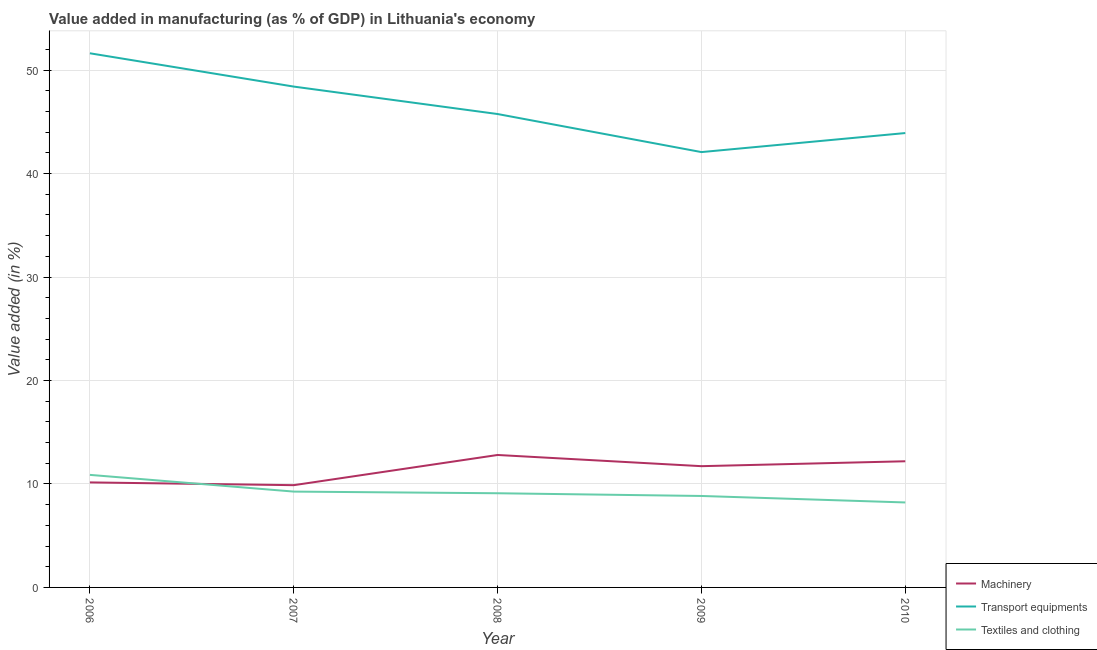How many different coloured lines are there?
Provide a succinct answer. 3. Is the number of lines equal to the number of legend labels?
Provide a succinct answer. Yes. What is the value added in manufacturing textile and clothing in 2009?
Make the answer very short. 8.84. Across all years, what is the maximum value added in manufacturing textile and clothing?
Offer a terse response. 10.88. Across all years, what is the minimum value added in manufacturing transport equipments?
Your response must be concise. 42.08. What is the total value added in manufacturing machinery in the graph?
Keep it short and to the point. 56.75. What is the difference between the value added in manufacturing transport equipments in 2009 and that in 2010?
Offer a very short reply. -1.84. What is the difference between the value added in manufacturing machinery in 2008 and the value added in manufacturing textile and clothing in 2007?
Make the answer very short. 3.54. What is the average value added in manufacturing transport equipments per year?
Provide a succinct answer. 46.36. In the year 2009, what is the difference between the value added in manufacturing textile and clothing and value added in manufacturing machinery?
Your answer should be compact. -2.88. What is the ratio of the value added in manufacturing machinery in 2008 to that in 2010?
Make the answer very short. 1.05. Is the difference between the value added in manufacturing transport equipments in 2007 and 2008 greater than the difference between the value added in manufacturing textile and clothing in 2007 and 2008?
Your response must be concise. Yes. What is the difference between the highest and the second highest value added in manufacturing textile and clothing?
Your answer should be very brief. 1.62. What is the difference between the highest and the lowest value added in manufacturing textile and clothing?
Keep it short and to the point. 2.67. Is the sum of the value added in manufacturing textile and clothing in 2009 and 2010 greater than the maximum value added in manufacturing machinery across all years?
Your answer should be very brief. Yes. Is it the case that in every year, the sum of the value added in manufacturing machinery and value added in manufacturing transport equipments is greater than the value added in manufacturing textile and clothing?
Make the answer very short. Yes. Is the value added in manufacturing machinery strictly less than the value added in manufacturing transport equipments over the years?
Your answer should be compact. Yes. How many lines are there?
Offer a terse response. 3. Are the values on the major ticks of Y-axis written in scientific E-notation?
Your answer should be compact. No. Does the graph contain grids?
Provide a short and direct response. Yes. Where does the legend appear in the graph?
Keep it short and to the point. Bottom right. What is the title of the graph?
Make the answer very short. Value added in manufacturing (as % of GDP) in Lithuania's economy. Does "Transport equipments" appear as one of the legend labels in the graph?
Offer a terse response. Yes. What is the label or title of the Y-axis?
Give a very brief answer. Value added (in %). What is the Value added (in %) of Machinery in 2006?
Your answer should be very brief. 10.15. What is the Value added (in %) in Transport equipments in 2006?
Your response must be concise. 51.63. What is the Value added (in %) in Textiles and clothing in 2006?
Your response must be concise. 10.88. What is the Value added (in %) in Machinery in 2007?
Keep it short and to the point. 9.88. What is the Value added (in %) in Transport equipments in 2007?
Provide a succinct answer. 48.41. What is the Value added (in %) of Textiles and clothing in 2007?
Provide a short and direct response. 9.26. What is the Value added (in %) of Machinery in 2008?
Make the answer very short. 12.8. What is the Value added (in %) of Transport equipments in 2008?
Provide a succinct answer. 45.76. What is the Value added (in %) of Textiles and clothing in 2008?
Provide a succinct answer. 9.1. What is the Value added (in %) of Machinery in 2009?
Your answer should be compact. 11.72. What is the Value added (in %) of Transport equipments in 2009?
Offer a very short reply. 42.08. What is the Value added (in %) of Textiles and clothing in 2009?
Your answer should be compact. 8.84. What is the Value added (in %) of Machinery in 2010?
Give a very brief answer. 12.19. What is the Value added (in %) in Transport equipments in 2010?
Provide a succinct answer. 43.92. What is the Value added (in %) in Textiles and clothing in 2010?
Make the answer very short. 8.21. Across all years, what is the maximum Value added (in %) in Machinery?
Your answer should be compact. 12.8. Across all years, what is the maximum Value added (in %) in Transport equipments?
Offer a very short reply. 51.63. Across all years, what is the maximum Value added (in %) of Textiles and clothing?
Give a very brief answer. 10.88. Across all years, what is the minimum Value added (in %) of Machinery?
Your response must be concise. 9.88. Across all years, what is the minimum Value added (in %) of Transport equipments?
Provide a succinct answer. 42.08. Across all years, what is the minimum Value added (in %) in Textiles and clothing?
Ensure brevity in your answer.  8.21. What is the total Value added (in %) of Machinery in the graph?
Offer a very short reply. 56.75. What is the total Value added (in %) of Transport equipments in the graph?
Provide a short and direct response. 231.79. What is the total Value added (in %) of Textiles and clothing in the graph?
Keep it short and to the point. 46.3. What is the difference between the Value added (in %) of Machinery in 2006 and that in 2007?
Give a very brief answer. 0.27. What is the difference between the Value added (in %) of Transport equipments in 2006 and that in 2007?
Provide a short and direct response. 3.22. What is the difference between the Value added (in %) in Textiles and clothing in 2006 and that in 2007?
Your answer should be compact. 1.62. What is the difference between the Value added (in %) of Machinery in 2006 and that in 2008?
Provide a short and direct response. -2.65. What is the difference between the Value added (in %) in Transport equipments in 2006 and that in 2008?
Give a very brief answer. 5.87. What is the difference between the Value added (in %) in Textiles and clothing in 2006 and that in 2008?
Make the answer very short. 1.78. What is the difference between the Value added (in %) in Machinery in 2006 and that in 2009?
Provide a succinct answer. -1.57. What is the difference between the Value added (in %) in Transport equipments in 2006 and that in 2009?
Your response must be concise. 9.55. What is the difference between the Value added (in %) in Textiles and clothing in 2006 and that in 2009?
Provide a succinct answer. 2.04. What is the difference between the Value added (in %) of Machinery in 2006 and that in 2010?
Provide a short and direct response. -2.04. What is the difference between the Value added (in %) of Transport equipments in 2006 and that in 2010?
Your response must be concise. 7.71. What is the difference between the Value added (in %) in Textiles and clothing in 2006 and that in 2010?
Offer a terse response. 2.67. What is the difference between the Value added (in %) in Machinery in 2007 and that in 2008?
Make the answer very short. -2.92. What is the difference between the Value added (in %) in Transport equipments in 2007 and that in 2008?
Ensure brevity in your answer.  2.65. What is the difference between the Value added (in %) of Textiles and clothing in 2007 and that in 2008?
Make the answer very short. 0.16. What is the difference between the Value added (in %) of Machinery in 2007 and that in 2009?
Make the answer very short. -1.84. What is the difference between the Value added (in %) in Transport equipments in 2007 and that in 2009?
Make the answer very short. 6.33. What is the difference between the Value added (in %) of Textiles and clothing in 2007 and that in 2009?
Make the answer very short. 0.42. What is the difference between the Value added (in %) in Machinery in 2007 and that in 2010?
Give a very brief answer. -2.31. What is the difference between the Value added (in %) of Transport equipments in 2007 and that in 2010?
Your answer should be very brief. 4.49. What is the difference between the Value added (in %) of Textiles and clothing in 2007 and that in 2010?
Keep it short and to the point. 1.05. What is the difference between the Value added (in %) of Machinery in 2008 and that in 2009?
Your response must be concise. 1.08. What is the difference between the Value added (in %) of Transport equipments in 2008 and that in 2009?
Provide a succinct answer. 3.68. What is the difference between the Value added (in %) in Textiles and clothing in 2008 and that in 2009?
Offer a terse response. 0.26. What is the difference between the Value added (in %) of Machinery in 2008 and that in 2010?
Provide a short and direct response. 0.61. What is the difference between the Value added (in %) of Transport equipments in 2008 and that in 2010?
Ensure brevity in your answer.  1.84. What is the difference between the Value added (in %) of Textiles and clothing in 2008 and that in 2010?
Provide a succinct answer. 0.89. What is the difference between the Value added (in %) in Machinery in 2009 and that in 2010?
Offer a very short reply. -0.47. What is the difference between the Value added (in %) in Transport equipments in 2009 and that in 2010?
Your answer should be compact. -1.84. What is the difference between the Value added (in %) of Textiles and clothing in 2009 and that in 2010?
Provide a short and direct response. 0.63. What is the difference between the Value added (in %) of Machinery in 2006 and the Value added (in %) of Transport equipments in 2007?
Your answer should be compact. -38.26. What is the difference between the Value added (in %) of Machinery in 2006 and the Value added (in %) of Textiles and clothing in 2007?
Offer a very short reply. 0.89. What is the difference between the Value added (in %) of Transport equipments in 2006 and the Value added (in %) of Textiles and clothing in 2007?
Ensure brevity in your answer.  42.37. What is the difference between the Value added (in %) of Machinery in 2006 and the Value added (in %) of Transport equipments in 2008?
Your response must be concise. -35.61. What is the difference between the Value added (in %) of Machinery in 2006 and the Value added (in %) of Textiles and clothing in 2008?
Provide a short and direct response. 1.05. What is the difference between the Value added (in %) of Transport equipments in 2006 and the Value added (in %) of Textiles and clothing in 2008?
Your response must be concise. 42.53. What is the difference between the Value added (in %) in Machinery in 2006 and the Value added (in %) in Transport equipments in 2009?
Ensure brevity in your answer.  -31.93. What is the difference between the Value added (in %) of Machinery in 2006 and the Value added (in %) of Textiles and clothing in 2009?
Provide a succinct answer. 1.31. What is the difference between the Value added (in %) in Transport equipments in 2006 and the Value added (in %) in Textiles and clothing in 2009?
Keep it short and to the point. 42.79. What is the difference between the Value added (in %) of Machinery in 2006 and the Value added (in %) of Transport equipments in 2010?
Offer a very short reply. -33.77. What is the difference between the Value added (in %) in Machinery in 2006 and the Value added (in %) in Textiles and clothing in 2010?
Keep it short and to the point. 1.94. What is the difference between the Value added (in %) in Transport equipments in 2006 and the Value added (in %) in Textiles and clothing in 2010?
Ensure brevity in your answer.  43.41. What is the difference between the Value added (in %) in Machinery in 2007 and the Value added (in %) in Transport equipments in 2008?
Your response must be concise. -35.87. What is the difference between the Value added (in %) in Machinery in 2007 and the Value added (in %) in Textiles and clothing in 2008?
Ensure brevity in your answer.  0.78. What is the difference between the Value added (in %) of Transport equipments in 2007 and the Value added (in %) of Textiles and clothing in 2008?
Ensure brevity in your answer.  39.31. What is the difference between the Value added (in %) of Machinery in 2007 and the Value added (in %) of Transport equipments in 2009?
Offer a terse response. -32.2. What is the difference between the Value added (in %) of Machinery in 2007 and the Value added (in %) of Textiles and clothing in 2009?
Keep it short and to the point. 1.04. What is the difference between the Value added (in %) of Transport equipments in 2007 and the Value added (in %) of Textiles and clothing in 2009?
Provide a short and direct response. 39.57. What is the difference between the Value added (in %) of Machinery in 2007 and the Value added (in %) of Transport equipments in 2010?
Your response must be concise. -34.03. What is the difference between the Value added (in %) of Machinery in 2007 and the Value added (in %) of Textiles and clothing in 2010?
Your answer should be very brief. 1.67. What is the difference between the Value added (in %) of Transport equipments in 2007 and the Value added (in %) of Textiles and clothing in 2010?
Your answer should be compact. 40.2. What is the difference between the Value added (in %) in Machinery in 2008 and the Value added (in %) in Transport equipments in 2009?
Give a very brief answer. -29.28. What is the difference between the Value added (in %) of Machinery in 2008 and the Value added (in %) of Textiles and clothing in 2009?
Provide a short and direct response. 3.96. What is the difference between the Value added (in %) in Transport equipments in 2008 and the Value added (in %) in Textiles and clothing in 2009?
Offer a terse response. 36.92. What is the difference between the Value added (in %) of Machinery in 2008 and the Value added (in %) of Transport equipments in 2010?
Your answer should be compact. -31.12. What is the difference between the Value added (in %) in Machinery in 2008 and the Value added (in %) in Textiles and clothing in 2010?
Your response must be concise. 4.59. What is the difference between the Value added (in %) in Transport equipments in 2008 and the Value added (in %) in Textiles and clothing in 2010?
Your answer should be compact. 37.54. What is the difference between the Value added (in %) of Machinery in 2009 and the Value added (in %) of Transport equipments in 2010?
Make the answer very short. -32.2. What is the difference between the Value added (in %) of Machinery in 2009 and the Value added (in %) of Textiles and clothing in 2010?
Keep it short and to the point. 3.51. What is the difference between the Value added (in %) of Transport equipments in 2009 and the Value added (in %) of Textiles and clothing in 2010?
Make the answer very short. 33.87. What is the average Value added (in %) of Machinery per year?
Offer a very short reply. 11.35. What is the average Value added (in %) of Transport equipments per year?
Provide a short and direct response. 46.36. What is the average Value added (in %) of Textiles and clothing per year?
Your answer should be compact. 9.26. In the year 2006, what is the difference between the Value added (in %) in Machinery and Value added (in %) in Transport equipments?
Give a very brief answer. -41.48. In the year 2006, what is the difference between the Value added (in %) of Machinery and Value added (in %) of Textiles and clothing?
Ensure brevity in your answer.  -0.73. In the year 2006, what is the difference between the Value added (in %) in Transport equipments and Value added (in %) in Textiles and clothing?
Your response must be concise. 40.75. In the year 2007, what is the difference between the Value added (in %) of Machinery and Value added (in %) of Transport equipments?
Give a very brief answer. -38.53. In the year 2007, what is the difference between the Value added (in %) of Machinery and Value added (in %) of Textiles and clothing?
Keep it short and to the point. 0.62. In the year 2007, what is the difference between the Value added (in %) of Transport equipments and Value added (in %) of Textiles and clothing?
Give a very brief answer. 39.15. In the year 2008, what is the difference between the Value added (in %) in Machinery and Value added (in %) in Transport equipments?
Give a very brief answer. -32.95. In the year 2008, what is the difference between the Value added (in %) in Machinery and Value added (in %) in Textiles and clothing?
Ensure brevity in your answer.  3.7. In the year 2008, what is the difference between the Value added (in %) in Transport equipments and Value added (in %) in Textiles and clothing?
Your answer should be very brief. 36.65. In the year 2009, what is the difference between the Value added (in %) in Machinery and Value added (in %) in Transport equipments?
Offer a very short reply. -30.36. In the year 2009, what is the difference between the Value added (in %) of Machinery and Value added (in %) of Textiles and clothing?
Your answer should be compact. 2.88. In the year 2009, what is the difference between the Value added (in %) in Transport equipments and Value added (in %) in Textiles and clothing?
Your answer should be compact. 33.24. In the year 2010, what is the difference between the Value added (in %) in Machinery and Value added (in %) in Transport equipments?
Your answer should be compact. -31.72. In the year 2010, what is the difference between the Value added (in %) of Machinery and Value added (in %) of Textiles and clothing?
Give a very brief answer. 3.98. In the year 2010, what is the difference between the Value added (in %) in Transport equipments and Value added (in %) in Textiles and clothing?
Your answer should be very brief. 35.7. What is the ratio of the Value added (in %) of Machinery in 2006 to that in 2007?
Make the answer very short. 1.03. What is the ratio of the Value added (in %) of Transport equipments in 2006 to that in 2007?
Give a very brief answer. 1.07. What is the ratio of the Value added (in %) of Textiles and clothing in 2006 to that in 2007?
Give a very brief answer. 1.17. What is the ratio of the Value added (in %) of Machinery in 2006 to that in 2008?
Your answer should be very brief. 0.79. What is the ratio of the Value added (in %) of Transport equipments in 2006 to that in 2008?
Give a very brief answer. 1.13. What is the ratio of the Value added (in %) of Textiles and clothing in 2006 to that in 2008?
Make the answer very short. 1.2. What is the ratio of the Value added (in %) in Machinery in 2006 to that in 2009?
Give a very brief answer. 0.87. What is the ratio of the Value added (in %) in Transport equipments in 2006 to that in 2009?
Make the answer very short. 1.23. What is the ratio of the Value added (in %) in Textiles and clothing in 2006 to that in 2009?
Keep it short and to the point. 1.23. What is the ratio of the Value added (in %) in Machinery in 2006 to that in 2010?
Your answer should be very brief. 0.83. What is the ratio of the Value added (in %) in Transport equipments in 2006 to that in 2010?
Your response must be concise. 1.18. What is the ratio of the Value added (in %) of Textiles and clothing in 2006 to that in 2010?
Your answer should be very brief. 1.32. What is the ratio of the Value added (in %) of Machinery in 2007 to that in 2008?
Provide a short and direct response. 0.77. What is the ratio of the Value added (in %) of Transport equipments in 2007 to that in 2008?
Provide a short and direct response. 1.06. What is the ratio of the Value added (in %) in Textiles and clothing in 2007 to that in 2008?
Keep it short and to the point. 1.02. What is the ratio of the Value added (in %) in Machinery in 2007 to that in 2009?
Offer a terse response. 0.84. What is the ratio of the Value added (in %) of Transport equipments in 2007 to that in 2009?
Keep it short and to the point. 1.15. What is the ratio of the Value added (in %) in Textiles and clothing in 2007 to that in 2009?
Your answer should be compact. 1.05. What is the ratio of the Value added (in %) of Machinery in 2007 to that in 2010?
Your answer should be compact. 0.81. What is the ratio of the Value added (in %) in Transport equipments in 2007 to that in 2010?
Ensure brevity in your answer.  1.1. What is the ratio of the Value added (in %) of Textiles and clothing in 2007 to that in 2010?
Provide a succinct answer. 1.13. What is the ratio of the Value added (in %) in Machinery in 2008 to that in 2009?
Your answer should be very brief. 1.09. What is the ratio of the Value added (in %) of Transport equipments in 2008 to that in 2009?
Ensure brevity in your answer.  1.09. What is the ratio of the Value added (in %) of Textiles and clothing in 2008 to that in 2009?
Offer a very short reply. 1.03. What is the ratio of the Value added (in %) of Machinery in 2008 to that in 2010?
Give a very brief answer. 1.05. What is the ratio of the Value added (in %) of Transport equipments in 2008 to that in 2010?
Your response must be concise. 1.04. What is the ratio of the Value added (in %) in Textiles and clothing in 2008 to that in 2010?
Your answer should be very brief. 1.11. What is the ratio of the Value added (in %) of Machinery in 2009 to that in 2010?
Your answer should be very brief. 0.96. What is the ratio of the Value added (in %) of Transport equipments in 2009 to that in 2010?
Your response must be concise. 0.96. What is the ratio of the Value added (in %) in Textiles and clothing in 2009 to that in 2010?
Your answer should be very brief. 1.08. What is the difference between the highest and the second highest Value added (in %) of Machinery?
Offer a terse response. 0.61. What is the difference between the highest and the second highest Value added (in %) in Transport equipments?
Make the answer very short. 3.22. What is the difference between the highest and the second highest Value added (in %) in Textiles and clothing?
Your response must be concise. 1.62. What is the difference between the highest and the lowest Value added (in %) in Machinery?
Provide a short and direct response. 2.92. What is the difference between the highest and the lowest Value added (in %) of Transport equipments?
Keep it short and to the point. 9.55. What is the difference between the highest and the lowest Value added (in %) in Textiles and clothing?
Your answer should be compact. 2.67. 